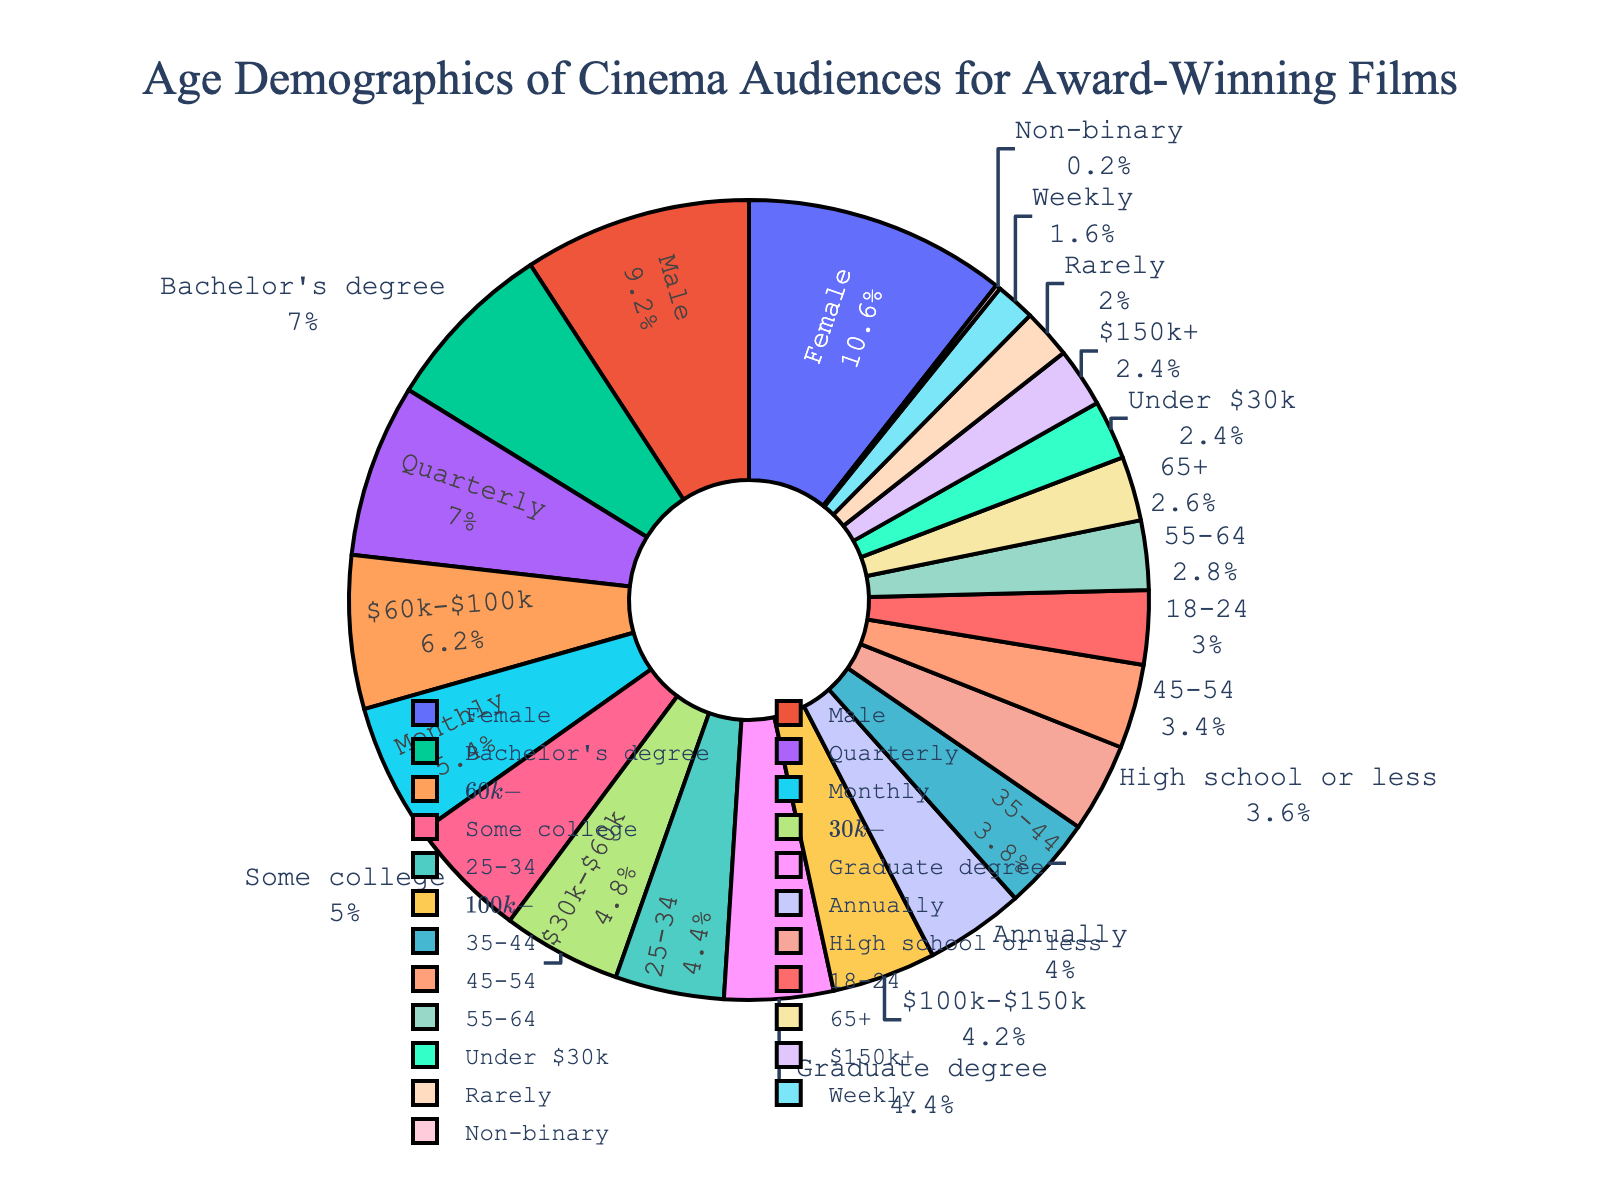What is the most represented age group in the cinema audience for award-winning films? The largest segment on the pie chart corresponds to '25-34' with 22%.
Answer: 25-34 Which two age groups together make up more than 40% of the cinema audience? Adding the percentages for '25-34' (22%) and '35-44' (19%) gives 41%, exceeding 40%.
Answer: 25-34 and 35-44 What is the difference in percentage between the youngest and oldest age groups? '18-24' represents 15% while '65+' represents 13%. The difference is 15% - 13% = 2%.
Answer: 2% How much higher is the 25-34 age group's representation compared to the 55-64 age group? The '25-34' age group is 22% and the '55-64' age group is 14%. The difference is 22% - 14% = 8%.
Answer: 8% Which age group corresponds to the smallest portion of the audience, and what is its percentage? The slice representing '65+' is the smallest, corresponding to 13%.
Answer: 65+, 13% If we combine the percentages of the 35-44 and 45-54 age groups, what percentage of the audience do they make up? Summing the percentages of '35-44' (19%) and '45-54' (17%) gives 19% + 17% = 36%.
Answer: 36% What is the combined percentage of all age groups under 35 years old? Summing the percentages of '18-24' (15%) and '25-34' (22%) gives 15% + 22% = 37%.
Answer: 37% Which age group is represented by the blue slice on the chart? By looking at the color coding, the blue slice corresponds to the '35-44' age group.
Answer: 35-44 How much more represented is the 25-34 age group compared to the 18-24 age group? The '25-34' age group is 22%, and the '18-24' age group is 15%. The difference is 22% - 15% = 7%.
Answer: 7% What percentage of the audience is 45 or older? Adding the percentages of '45-54' (17%), '55-64' (14%), and '65+' (13%) gives 17% + 14% + 13% = 44%.
Answer: 44% 